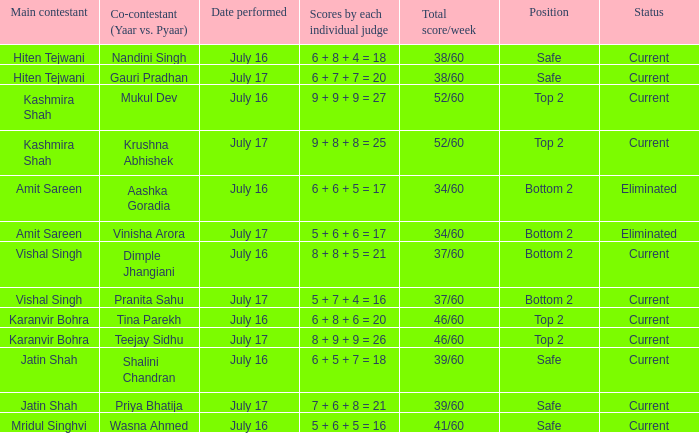With a 41/60 total score, what was the team's placement? Safe. 